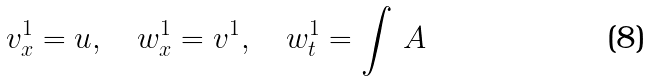Convert formula to latex. <formula><loc_0><loc_0><loc_500><loc_500>v ^ { 1 } _ { x } = u , \quad w ^ { 1 } _ { x } = v ^ { 1 } , \quad w ^ { 1 } _ { t } = \int \, A</formula> 